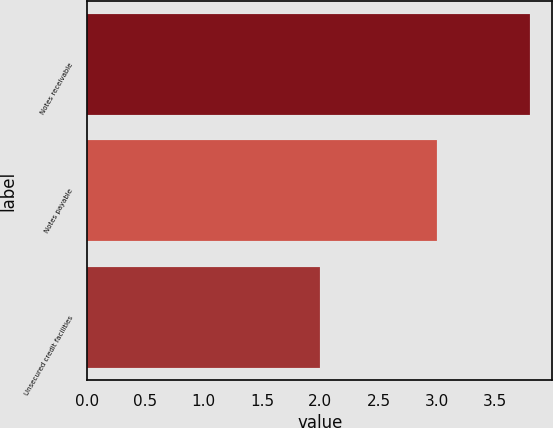Convert chart to OTSL. <chart><loc_0><loc_0><loc_500><loc_500><bar_chart><fcel>Notes receivable<fcel>Notes payable<fcel>Unsecured credit facilities<nl><fcel>3.8<fcel>3<fcel>2<nl></chart> 